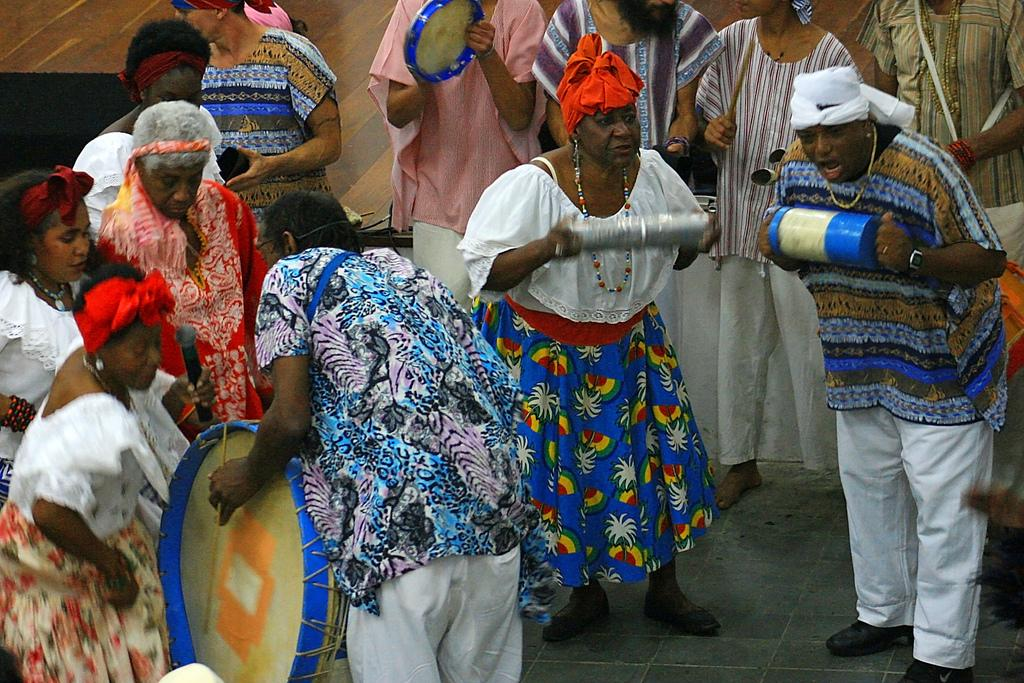How many people are in the image? There is a group of people in the image, but the exact number is not specified. What are the people doing in the image? The people are standing on the ground. What type of juice is being squeezed from the sponge in the image? There is no juice or sponge present in the image. How is the hose being used by the people in the image? There is no hose present in the image. 